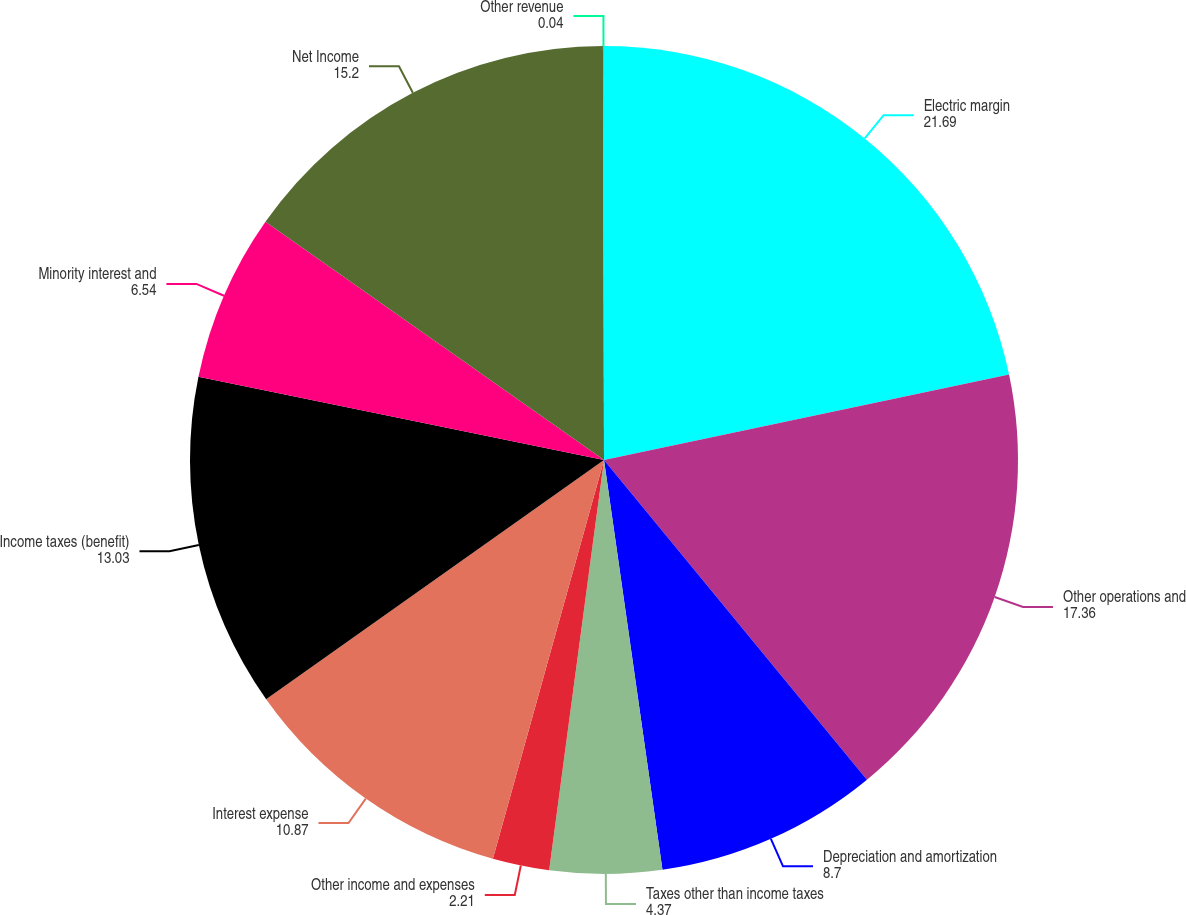Convert chart to OTSL. <chart><loc_0><loc_0><loc_500><loc_500><pie_chart><fcel>Electric margin<fcel>Other operations and<fcel>Depreciation and amortization<fcel>Taxes other than income taxes<fcel>Other income and expenses<fcel>Interest expense<fcel>Income taxes (benefit)<fcel>Minority interest and<fcel>Net Income<fcel>Other revenue<nl><fcel>21.69%<fcel>17.36%<fcel>8.7%<fcel>4.37%<fcel>2.21%<fcel>10.87%<fcel>13.03%<fcel>6.54%<fcel>15.2%<fcel>0.04%<nl></chart> 